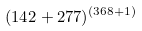<formula> <loc_0><loc_0><loc_500><loc_500>( 1 4 2 + 2 7 7 ) ^ { ( 3 6 8 + 1 ) }</formula> 